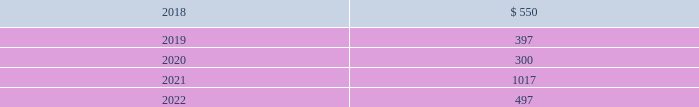In january 2016 , the company issued $ 800 million of debt securities consisting of a $ 400 million aggregate principal three year fixed rate note with a coupon rate of 2.00% ( 2.00 % ) and a $ 400 million aggregate principal seven year fixed rate note with a coupon rate of 3.25% ( 3.25 % ) .
The proceeds were used to repay a portion of the company 2019s outstanding commercial paper , repay the remaining term loan balance , and for general corporate purposes .
The company 2019s public notes and 144a notes may be redeemed by the company at its option at redemption prices that include accrued and unpaid interest and a make-whole premium .
Upon the occurrence of a change of control accompanied by a downgrade of the notes below investment grade rating , within a specified time period , the company would be required to offer to repurchase the public notes and 144a notes at a price equal to 101% ( 101 % ) of the aggregate principal amount thereof , plus any accrued and unpaid interest to the date of repurchase .
The public notes and 144a notes are senior unsecured and unsubordinated obligations of the company and rank equally with all other senior and unsubordinated indebtedness of the company .
The company entered into a registration rights agreement in connection with the issuance of the 144a notes .
Subject to certain limitations set forth in the registration rights agreement , the company has agreed to ( i ) file a registration statement ( the 201cexchange offer registration statement 201d ) with respect to registered offers to exchange the 144a notes for exchange notes ( the 201cexchange notes 201d ) , which will have terms identical in all material respects to the new 10-year notes and new 30-year notes , as applicable , except that the exchange notes will not contain transfer restrictions and will not provide for any increase in the interest rate thereon in certain circumstances and ( ii ) use commercially reasonable efforts to cause the exchange offer registration statement to be declared effective within 270 days after the date of issuance of the 144a notes .
Until such time as the exchange offer registration statement is declared effective , the 144a notes may only be sold in accordance with rule 144a or regulation s of the securities act of 1933 , as amended .
Private notes the company 2019s private notes may be redeemed by the company at its option at redemption prices that include accrued and unpaid interest and a make-whole premium .
Upon the occurrence of specified changes of control involving the company , the company would be required to offer to repurchase the private notes at a price equal to 100% ( 100 % ) of the aggregate principal amount thereof , plus any accrued and unpaid interest to the date of repurchase .
Additionally , the company would be required to make a similar offer to repurchase the private notes upon the occurrence of specified merger events or asset sales involving the company , when accompanied by a downgrade of the private notes below investment grade rating , within a specified time period .
The private notes are unsecured senior obligations of the company and rank equal in right of payment with all other senior indebtedness of the company .
The private notes shall be unconditionally guaranteed by subsidiaries of the company in certain circumstances , as described in the note purchase agreements as amended .
Other debt during 2015 , the company acquired the beneficial interest in the trust owning the leased naperville facility resulting in debt assumption of $ 100.2 million and the addition of $ 135.2 million in property , plant and equipment .
Certain administrative , divisional , and research and development personnel are based at the naperville facility .
Cash paid as a result of the transaction was $ 19.8 million .
The assumption of debt and the majority of the property , plant and equipment addition represented non-cash financing and investing activities , respectively .
The remaining balance on the assumed debt was settled in december 2017 and was reflected in the "other" line of the table above at december 31 , 2016 .
Covenants and future maturities the company is in compliance with all covenants under the company 2019s outstanding indebtedness at december 31 , 2017 .
As of december 31 , 2017 , the aggregate annual maturities of long-term debt for the next five years were : ( millions ) .

Is the long term debt maturing in 2021 greater than 2022? 
Computations: (1017 > 497)
Answer: yes. 